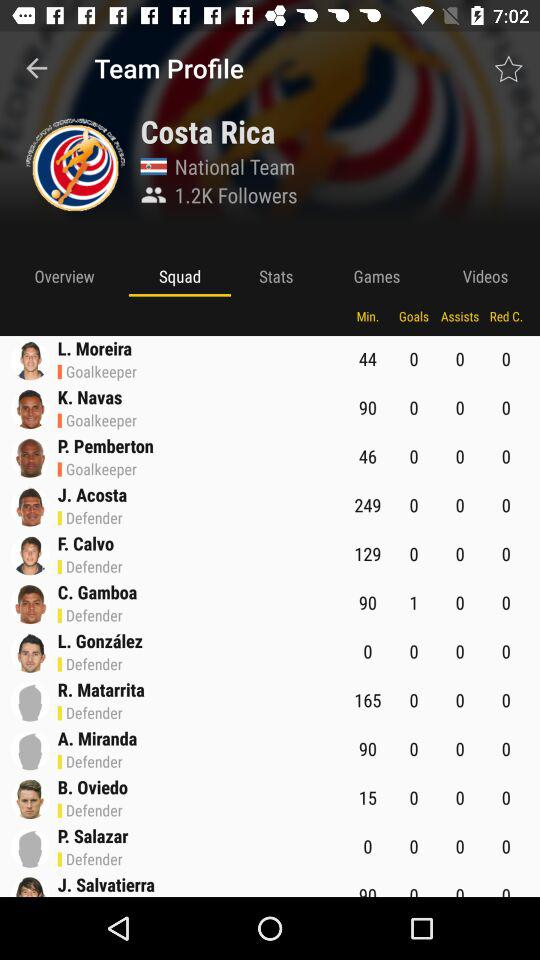What is the name of the team? The name of the team is "Costa Rica". 